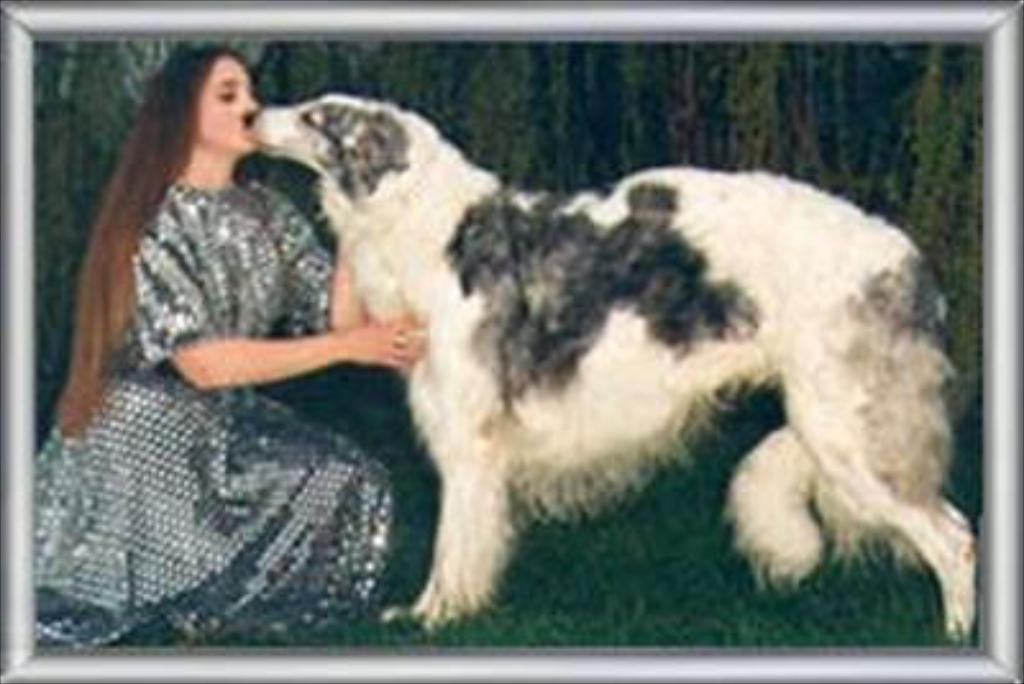What is the main subject of the painting in the image? The painting depicts a girl. What is the girl doing in the painting? The girl is kissing a dog in the painting. Where is the dog positioned in relation to the girl? The dog is in front of the girl in the painting. What type of noise can be heard coming from the painting? There is no noise present in the painting; it is a static image. Is the painting a print or an original? The provided facts do not specify whether the painting is a print or an original. 